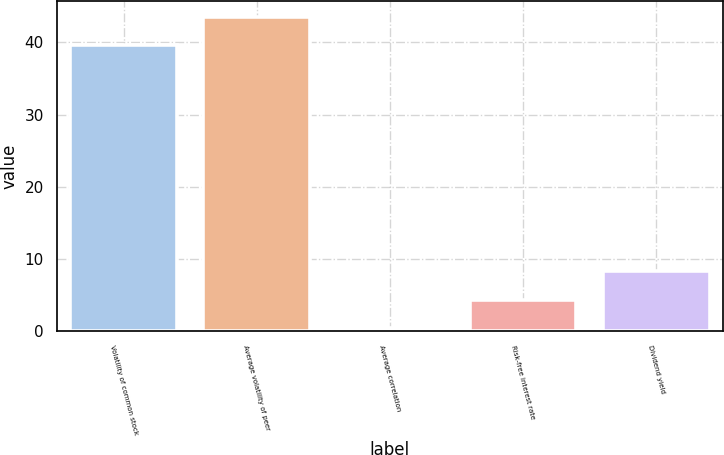Convert chart to OTSL. <chart><loc_0><loc_0><loc_500><loc_500><bar_chart><fcel>Volatility of common stock<fcel>Average volatility of peer<fcel>Average correlation<fcel>Risk-free interest rate<fcel>Dividend yield<nl><fcel>39.6<fcel>43.54<fcel>0.42<fcel>4.36<fcel>8.3<nl></chart> 